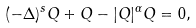<formula> <loc_0><loc_0><loc_500><loc_500>( - \Delta ) ^ { s } Q + Q - | Q | ^ { \alpha } Q = 0 ,</formula> 